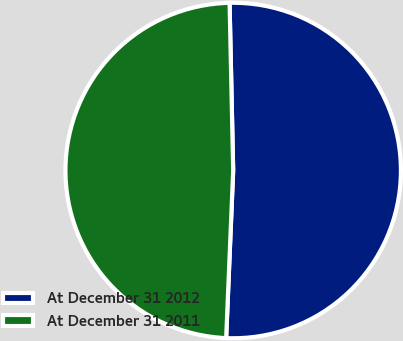Convert chart to OTSL. <chart><loc_0><loc_0><loc_500><loc_500><pie_chart><fcel>At December 31 2012<fcel>At December 31 2011<nl><fcel>51.01%<fcel>48.99%<nl></chart> 